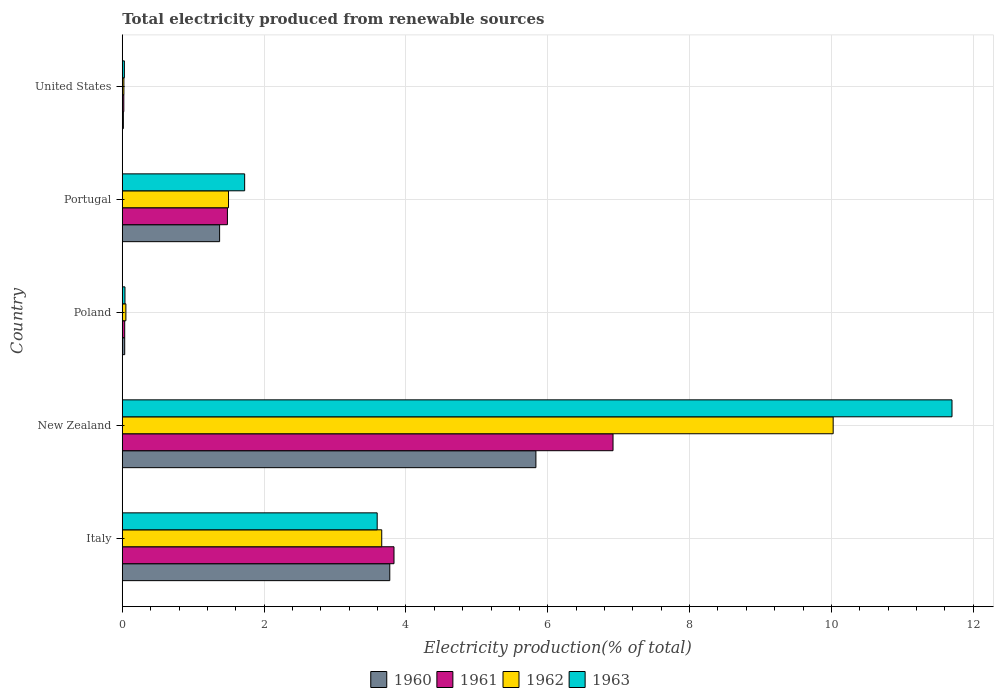How many different coloured bars are there?
Your answer should be very brief. 4. How many groups of bars are there?
Provide a short and direct response. 5. Are the number of bars per tick equal to the number of legend labels?
Your response must be concise. Yes. Are the number of bars on each tick of the Y-axis equal?
Provide a short and direct response. Yes. What is the label of the 1st group of bars from the top?
Offer a terse response. United States. What is the total electricity produced in 1963 in Poland?
Your answer should be compact. 0.04. Across all countries, what is the maximum total electricity produced in 1962?
Your answer should be very brief. 10.02. Across all countries, what is the minimum total electricity produced in 1962?
Keep it short and to the point. 0.02. In which country was the total electricity produced in 1962 maximum?
Your response must be concise. New Zealand. What is the total total electricity produced in 1963 in the graph?
Keep it short and to the point. 17.09. What is the difference between the total electricity produced in 1960 in Poland and that in United States?
Provide a succinct answer. 0.02. What is the difference between the total electricity produced in 1960 in Italy and the total electricity produced in 1961 in Portugal?
Your answer should be compact. 2.29. What is the average total electricity produced in 1960 per country?
Provide a short and direct response. 2.21. What is the difference between the total electricity produced in 1961 and total electricity produced in 1962 in Poland?
Your answer should be very brief. -0.02. In how many countries, is the total electricity produced in 1960 greater than 1.2000000000000002 %?
Offer a terse response. 3. What is the ratio of the total electricity produced in 1963 in Italy to that in United States?
Keep it short and to the point. 122.12. Is the total electricity produced in 1961 in Italy less than that in United States?
Provide a short and direct response. No. Is the difference between the total electricity produced in 1961 in New Zealand and Poland greater than the difference between the total electricity produced in 1962 in New Zealand and Poland?
Keep it short and to the point. No. What is the difference between the highest and the second highest total electricity produced in 1960?
Ensure brevity in your answer.  2.06. What is the difference between the highest and the lowest total electricity produced in 1962?
Offer a very short reply. 10. In how many countries, is the total electricity produced in 1963 greater than the average total electricity produced in 1963 taken over all countries?
Your answer should be compact. 2. What does the 2nd bar from the top in New Zealand represents?
Make the answer very short. 1962. Is it the case that in every country, the sum of the total electricity produced in 1961 and total electricity produced in 1962 is greater than the total electricity produced in 1960?
Keep it short and to the point. Yes. How many countries are there in the graph?
Your response must be concise. 5. What is the difference between two consecutive major ticks on the X-axis?
Provide a short and direct response. 2. Does the graph contain any zero values?
Provide a short and direct response. No. Does the graph contain grids?
Ensure brevity in your answer.  Yes. How are the legend labels stacked?
Ensure brevity in your answer.  Horizontal. What is the title of the graph?
Offer a terse response. Total electricity produced from renewable sources. What is the Electricity production(% of total) in 1960 in Italy?
Offer a terse response. 3.77. What is the Electricity production(% of total) of 1961 in Italy?
Provide a succinct answer. 3.83. What is the Electricity production(% of total) in 1962 in Italy?
Your answer should be compact. 3.66. What is the Electricity production(% of total) of 1963 in Italy?
Give a very brief answer. 3.59. What is the Electricity production(% of total) in 1960 in New Zealand?
Offer a terse response. 5.83. What is the Electricity production(% of total) in 1961 in New Zealand?
Keep it short and to the point. 6.92. What is the Electricity production(% of total) in 1962 in New Zealand?
Keep it short and to the point. 10.02. What is the Electricity production(% of total) of 1963 in New Zealand?
Provide a short and direct response. 11.7. What is the Electricity production(% of total) in 1960 in Poland?
Offer a terse response. 0.03. What is the Electricity production(% of total) in 1961 in Poland?
Offer a terse response. 0.03. What is the Electricity production(% of total) in 1962 in Poland?
Offer a terse response. 0.05. What is the Electricity production(% of total) in 1963 in Poland?
Your response must be concise. 0.04. What is the Electricity production(% of total) in 1960 in Portugal?
Provide a short and direct response. 1.37. What is the Electricity production(% of total) of 1961 in Portugal?
Make the answer very short. 1.48. What is the Electricity production(% of total) of 1962 in Portugal?
Ensure brevity in your answer.  1.5. What is the Electricity production(% of total) of 1963 in Portugal?
Ensure brevity in your answer.  1.73. What is the Electricity production(% of total) in 1960 in United States?
Provide a succinct answer. 0.02. What is the Electricity production(% of total) in 1961 in United States?
Offer a very short reply. 0.02. What is the Electricity production(% of total) of 1962 in United States?
Offer a terse response. 0.02. What is the Electricity production(% of total) in 1963 in United States?
Your answer should be compact. 0.03. Across all countries, what is the maximum Electricity production(% of total) of 1960?
Offer a very short reply. 5.83. Across all countries, what is the maximum Electricity production(% of total) of 1961?
Provide a short and direct response. 6.92. Across all countries, what is the maximum Electricity production(% of total) of 1962?
Make the answer very short. 10.02. Across all countries, what is the maximum Electricity production(% of total) of 1963?
Provide a short and direct response. 11.7. Across all countries, what is the minimum Electricity production(% of total) in 1960?
Keep it short and to the point. 0.02. Across all countries, what is the minimum Electricity production(% of total) in 1961?
Keep it short and to the point. 0.02. Across all countries, what is the minimum Electricity production(% of total) of 1962?
Your answer should be very brief. 0.02. Across all countries, what is the minimum Electricity production(% of total) in 1963?
Make the answer very short. 0.03. What is the total Electricity production(% of total) of 1960 in the graph?
Make the answer very short. 11.03. What is the total Electricity production(% of total) in 1961 in the graph?
Provide a short and direct response. 12.29. What is the total Electricity production(% of total) in 1962 in the graph?
Your answer should be compact. 15.25. What is the total Electricity production(% of total) in 1963 in the graph?
Ensure brevity in your answer.  17.09. What is the difference between the Electricity production(% of total) in 1960 in Italy and that in New Zealand?
Your answer should be very brief. -2.06. What is the difference between the Electricity production(% of total) in 1961 in Italy and that in New Zealand?
Make the answer very short. -3.09. What is the difference between the Electricity production(% of total) of 1962 in Italy and that in New Zealand?
Provide a succinct answer. -6.37. What is the difference between the Electricity production(% of total) of 1963 in Italy and that in New Zealand?
Give a very brief answer. -8.11. What is the difference between the Electricity production(% of total) of 1960 in Italy and that in Poland?
Provide a succinct answer. 3.74. What is the difference between the Electricity production(% of total) of 1961 in Italy and that in Poland?
Your answer should be compact. 3.8. What is the difference between the Electricity production(% of total) of 1962 in Italy and that in Poland?
Provide a short and direct response. 3.61. What is the difference between the Electricity production(% of total) of 1963 in Italy and that in Poland?
Give a very brief answer. 3.56. What is the difference between the Electricity production(% of total) in 1960 in Italy and that in Portugal?
Your answer should be very brief. 2.4. What is the difference between the Electricity production(% of total) in 1961 in Italy and that in Portugal?
Your response must be concise. 2.35. What is the difference between the Electricity production(% of total) in 1962 in Italy and that in Portugal?
Provide a succinct answer. 2.16. What is the difference between the Electricity production(% of total) of 1963 in Italy and that in Portugal?
Offer a terse response. 1.87. What is the difference between the Electricity production(% of total) of 1960 in Italy and that in United States?
Your answer should be compact. 3.76. What is the difference between the Electricity production(% of total) of 1961 in Italy and that in United States?
Give a very brief answer. 3.81. What is the difference between the Electricity production(% of total) in 1962 in Italy and that in United States?
Make the answer very short. 3.64. What is the difference between the Electricity production(% of total) in 1963 in Italy and that in United States?
Keep it short and to the point. 3.56. What is the difference between the Electricity production(% of total) of 1960 in New Zealand and that in Poland?
Provide a short and direct response. 5.8. What is the difference between the Electricity production(% of total) of 1961 in New Zealand and that in Poland?
Give a very brief answer. 6.89. What is the difference between the Electricity production(% of total) in 1962 in New Zealand and that in Poland?
Make the answer very short. 9.97. What is the difference between the Electricity production(% of total) of 1963 in New Zealand and that in Poland?
Provide a succinct answer. 11.66. What is the difference between the Electricity production(% of total) in 1960 in New Zealand and that in Portugal?
Keep it short and to the point. 4.46. What is the difference between the Electricity production(% of total) in 1961 in New Zealand and that in Portugal?
Your response must be concise. 5.44. What is the difference between the Electricity production(% of total) of 1962 in New Zealand and that in Portugal?
Offer a terse response. 8.53. What is the difference between the Electricity production(% of total) in 1963 in New Zealand and that in Portugal?
Provide a short and direct response. 9.97. What is the difference between the Electricity production(% of total) of 1960 in New Zealand and that in United States?
Offer a very short reply. 5.82. What is the difference between the Electricity production(% of total) in 1961 in New Zealand and that in United States?
Provide a short and direct response. 6.9. What is the difference between the Electricity production(% of total) of 1962 in New Zealand and that in United States?
Give a very brief answer. 10. What is the difference between the Electricity production(% of total) in 1963 in New Zealand and that in United States?
Offer a very short reply. 11.67. What is the difference between the Electricity production(% of total) in 1960 in Poland and that in Portugal?
Provide a short and direct response. -1.34. What is the difference between the Electricity production(% of total) of 1961 in Poland and that in Portugal?
Offer a very short reply. -1.45. What is the difference between the Electricity production(% of total) of 1962 in Poland and that in Portugal?
Offer a terse response. -1.45. What is the difference between the Electricity production(% of total) of 1963 in Poland and that in Portugal?
Offer a terse response. -1.69. What is the difference between the Electricity production(% of total) of 1960 in Poland and that in United States?
Give a very brief answer. 0.02. What is the difference between the Electricity production(% of total) of 1961 in Poland and that in United States?
Your answer should be very brief. 0.01. What is the difference between the Electricity production(% of total) of 1962 in Poland and that in United States?
Your answer should be compact. 0.03. What is the difference between the Electricity production(% of total) in 1963 in Poland and that in United States?
Your answer should be very brief. 0.01. What is the difference between the Electricity production(% of total) in 1960 in Portugal and that in United States?
Offer a very short reply. 1.36. What is the difference between the Electricity production(% of total) of 1961 in Portugal and that in United States?
Give a very brief answer. 1.46. What is the difference between the Electricity production(% of total) in 1962 in Portugal and that in United States?
Offer a terse response. 1.48. What is the difference between the Electricity production(% of total) of 1963 in Portugal and that in United States?
Your answer should be very brief. 1.7. What is the difference between the Electricity production(% of total) in 1960 in Italy and the Electricity production(% of total) in 1961 in New Zealand?
Your response must be concise. -3.15. What is the difference between the Electricity production(% of total) in 1960 in Italy and the Electricity production(% of total) in 1962 in New Zealand?
Offer a very short reply. -6.25. What is the difference between the Electricity production(% of total) in 1960 in Italy and the Electricity production(% of total) in 1963 in New Zealand?
Your answer should be compact. -7.93. What is the difference between the Electricity production(% of total) of 1961 in Italy and the Electricity production(% of total) of 1962 in New Zealand?
Your answer should be very brief. -6.19. What is the difference between the Electricity production(% of total) of 1961 in Italy and the Electricity production(% of total) of 1963 in New Zealand?
Offer a terse response. -7.87. What is the difference between the Electricity production(% of total) of 1962 in Italy and the Electricity production(% of total) of 1963 in New Zealand?
Ensure brevity in your answer.  -8.04. What is the difference between the Electricity production(% of total) in 1960 in Italy and the Electricity production(% of total) in 1961 in Poland?
Ensure brevity in your answer.  3.74. What is the difference between the Electricity production(% of total) of 1960 in Italy and the Electricity production(% of total) of 1962 in Poland?
Your answer should be compact. 3.72. What is the difference between the Electricity production(% of total) in 1960 in Italy and the Electricity production(% of total) in 1963 in Poland?
Your answer should be very brief. 3.73. What is the difference between the Electricity production(% of total) of 1961 in Italy and the Electricity production(% of total) of 1962 in Poland?
Your response must be concise. 3.78. What is the difference between the Electricity production(% of total) in 1961 in Italy and the Electricity production(% of total) in 1963 in Poland?
Offer a very short reply. 3.79. What is the difference between the Electricity production(% of total) in 1962 in Italy and the Electricity production(% of total) in 1963 in Poland?
Your answer should be compact. 3.62. What is the difference between the Electricity production(% of total) of 1960 in Italy and the Electricity production(% of total) of 1961 in Portugal?
Provide a succinct answer. 2.29. What is the difference between the Electricity production(% of total) in 1960 in Italy and the Electricity production(% of total) in 1962 in Portugal?
Offer a terse response. 2.27. What is the difference between the Electricity production(% of total) of 1960 in Italy and the Electricity production(% of total) of 1963 in Portugal?
Your answer should be very brief. 2.05. What is the difference between the Electricity production(% of total) in 1961 in Italy and the Electricity production(% of total) in 1962 in Portugal?
Provide a short and direct response. 2.33. What is the difference between the Electricity production(% of total) of 1961 in Italy and the Electricity production(% of total) of 1963 in Portugal?
Offer a very short reply. 2.11. What is the difference between the Electricity production(% of total) of 1962 in Italy and the Electricity production(% of total) of 1963 in Portugal?
Offer a very short reply. 1.93. What is the difference between the Electricity production(% of total) in 1960 in Italy and the Electricity production(% of total) in 1961 in United States?
Ensure brevity in your answer.  3.75. What is the difference between the Electricity production(% of total) in 1960 in Italy and the Electricity production(% of total) in 1962 in United States?
Your answer should be compact. 3.75. What is the difference between the Electricity production(% of total) of 1960 in Italy and the Electricity production(% of total) of 1963 in United States?
Offer a very short reply. 3.74. What is the difference between the Electricity production(% of total) of 1961 in Italy and the Electricity production(% of total) of 1962 in United States?
Give a very brief answer. 3.81. What is the difference between the Electricity production(% of total) of 1961 in Italy and the Electricity production(% of total) of 1963 in United States?
Keep it short and to the point. 3.8. What is the difference between the Electricity production(% of total) of 1962 in Italy and the Electricity production(% of total) of 1963 in United States?
Give a very brief answer. 3.63. What is the difference between the Electricity production(% of total) of 1960 in New Zealand and the Electricity production(% of total) of 1961 in Poland?
Provide a short and direct response. 5.8. What is the difference between the Electricity production(% of total) in 1960 in New Zealand and the Electricity production(% of total) in 1962 in Poland?
Offer a very short reply. 5.78. What is the difference between the Electricity production(% of total) in 1960 in New Zealand and the Electricity production(% of total) in 1963 in Poland?
Ensure brevity in your answer.  5.79. What is the difference between the Electricity production(% of total) in 1961 in New Zealand and the Electricity production(% of total) in 1962 in Poland?
Keep it short and to the point. 6.87. What is the difference between the Electricity production(% of total) of 1961 in New Zealand and the Electricity production(% of total) of 1963 in Poland?
Give a very brief answer. 6.88. What is the difference between the Electricity production(% of total) in 1962 in New Zealand and the Electricity production(% of total) in 1963 in Poland?
Give a very brief answer. 9.99. What is the difference between the Electricity production(% of total) in 1960 in New Zealand and the Electricity production(% of total) in 1961 in Portugal?
Provide a short and direct response. 4.35. What is the difference between the Electricity production(% of total) of 1960 in New Zealand and the Electricity production(% of total) of 1962 in Portugal?
Give a very brief answer. 4.33. What is the difference between the Electricity production(% of total) of 1960 in New Zealand and the Electricity production(% of total) of 1963 in Portugal?
Keep it short and to the point. 4.11. What is the difference between the Electricity production(% of total) in 1961 in New Zealand and the Electricity production(% of total) in 1962 in Portugal?
Keep it short and to the point. 5.42. What is the difference between the Electricity production(% of total) in 1961 in New Zealand and the Electricity production(% of total) in 1963 in Portugal?
Your answer should be compact. 5.19. What is the difference between the Electricity production(% of total) in 1962 in New Zealand and the Electricity production(% of total) in 1963 in Portugal?
Provide a short and direct response. 8.3. What is the difference between the Electricity production(% of total) in 1960 in New Zealand and the Electricity production(% of total) in 1961 in United States?
Provide a short and direct response. 5.81. What is the difference between the Electricity production(% of total) in 1960 in New Zealand and the Electricity production(% of total) in 1962 in United States?
Give a very brief answer. 5.81. What is the difference between the Electricity production(% of total) in 1960 in New Zealand and the Electricity production(% of total) in 1963 in United States?
Keep it short and to the point. 5.8. What is the difference between the Electricity production(% of total) of 1961 in New Zealand and the Electricity production(% of total) of 1962 in United States?
Provide a succinct answer. 6.9. What is the difference between the Electricity production(% of total) in 1961 in New Zealand and the Electricity production(% of total) in 1963 in United States?
Make the answer very short. 6.89. What is the difference between the Electricity production(% of total) in 1962 in New Zealand and the Electricity production(% of total) in 1963 in United States?
Ensure brevity in your answer.  10. What is the difference between the Electricity production(% of total) of 1960 in Poland and the Electricity production(% of total) of 1961 in Portugal?
Offer a very short reply. -1.45. What is the difference between the Electricity production(% of total) in 1960 in Poland and the Electricity production(% of total) in 1962 in Portugal?
Give a very brief answer. -1.46. What is the difference between the Electricity production(% of total) in 1960 in Poland and the Electricity production(% of total) in 1963 in Portugal?
Provide a succinct answer. -1.69. What is the difference between the Electricity production(% of total) of 1961 in Poland and the Electricity production(% of total) of 1962 in Portugal?
Your answer should be compact. -1.46. What is the difference between the Electricity production(% of total) in 1961 in Poland and the Electricity production(% of total) in 1963 in Portugal?
Offer a terse response. -1.69. What is the difference between the Electricity production(% of total) of 1962 in Poland and the Electricity production(% of total) of 1963 in Portugal?
Your response must be concise. -1.67. What is the difference between the Electricity production(% of total) in 1960 in Poland and the Electricity production(% of total) in 1961 in United States?
Your response must be concise. 0.01. What is the difference between the Electricity production(% of total) of 1960 in Poland and the Electricity production(% of total) of 1962 in United States?
Your answer should be compact. 0.01. What is the difference between the Electricity production(% of total) of 1960 in Poland and the Electricity production(% of total) of 1963 in United States?
Give a very brief answer. 0. What is the difference between the Electricity production(% of total) in 1961 in Poland and the Electricity production(% of total) in 1962 in United States?
Ensure brevity in your answer.  0.01. What is the difference between the Electricity production(% of total) in 1961 in Poland and the Electricity production(% of total) in 1963 in United States?
Offer a very short reply. 0. What is the difference between the Electricity production(% of total) in 1962 in Poland and the Electricity production(% of total) in 1963 in United States?
Make the answer very short. 0.02. What is the difference between the Electricity production(% of total) of 1960 in Portugal and the Electricity production(% of total) of 1961 in United States?
Your response must be concise. 1.35. What is the difference between the Electricity production(% of total) in 1960 in Portugal and the Electricity production(% of total) in 1962 in United States?
Offer a very short reply. 1.35. What is the difference between the Electricity production(% of total) in 1960 in Portugal and the Electricity production(% of total) in 1963 in United States?
Offer a very short reply. 1.34. What is the difference between the Electricity production(% of total) of 1961 in Portugal and the Electricity production(% of total) of 1962 in United States?
Offer a terse response. 1.46. What is the difference between the Electricity production(% of total) in 1961 in Portugal and the Electricity production(% of total) in 1963 in United States?
Keep it short and to the point. 1.45. What is the difference between the Electricity production(% of total) in 1962 in Portugal and the Electricity production(% of total) in 1963 in United States?
Provide a succinct answer. 1.47. What is the average Electricity production(% of total) in 1960 per country?
Offer a terse response. 2.21. What is the average Electricity production(% of total) of 1961 per country?
Your response must be concise. 2.46. What is the average Electricity production(% of total) of 1962 per country?
Provide a succinct answer. 3.05. What is the average Electricity production(% of total) of 1963 per country?
Your answer should be very brief. 3.42. What is the difference between the Electricity production(% of total) of 1960 and Electricity production(% of total) of 1961 in Italy?
Provide a short and direct response. -0.06. What is the difference between the Electricity production(% of total) in 1960 and Electricity production(% of total) in 1962 in Italy?
Make the answer very short. 0.11. What is the difference between the Electricity production(% of total) in 1960 and Electricity production(% of total) in 1963 in Italy?
Ensure brevity in your answer.  0.18. What is the difference between the Electricity production(% of total) in 1961 and Electricity production(% of total) in 1962 in Italy?
Keep it short and to the point. 0.17. What is the difference between the Electricity production(% of total) of 1961 and Electricity production(% of total) of 1963 in Italy?
Provide a succinct answer. 0.24. What is the difference between the Electricity production(% of total) of 1962 and Electricity production(% of total) of 1963 in Italy?
Your answer should be very brief. 0.06. What is the difference between the Electricity production(% of total) in 1960 and Electricity production(% of total) in 1961 in New Zealand?
Keep it short and to the point. -1.09. What is the difference between the Electricity production(% of total) in 1960 and Electricity production(% of total) in 1962 in New Zealand?
Your response must be concise. -4.19. What is the difference between the Electricity production(% of total) in 1960 and Electricity production(% of total) in 1963 in New Zealand?
Keep it short and to the point. -5.87. What is the difference between the Electricity production(% of total) in 1961 and Electricity production(% of total) in 1962 in New Zealand?
Give a very brief answer. -3.1. What is the difference between the Electricity production(% of total) of 1961 and Electricity production(% of total) of 1963 in New Zealand?
Give a very brief answer. -4.78. What is the difference between the Electricity production(% of total) in 1962 and Electricity production(% of total) in 1963 in New Zealand?
Ensure brevity in your answer.  -1.68. What is the difference between the Electricity production(% of total) in 1960 and Electricity production(% of total) in 1961 in Poland?
Ensure brevity in your answer.  0. What is the difference between the Electricity production(% of total) in 1960 and Electricity production(% of total) in 1962 in Poland?
Provide a succinct answer. -0.02. What is the difference between the Electricity production(% of total) of 1960 and Electricity production(% of total) of 1963 in Poland?
Ensure brevity in your answer.  -0. What is the difference between the Electricity production(% of total) of 1961 and Electricity production(% of total) of 1962 in Poland?
Provide a short and direct response. -0.02. What is the difference between the Electricity production(% of total) in 1961 and Electricity production(% of total) in 1963 in Poland?
Give a very brief answer. -0. What is the difference between the Electricity production(% of total) of 1962 and Electricity production(% of total) of 1963 in Poland?
Offer a very short reply. 0.01. What is the difference between the Electricity production(% of total) in 1960 and Electricity production(% of total) in 1961 in Portugal?
Keep it short and to the point. -0.11. What is the difference between the Electricity production(% of total) in 1960 and Electricity production(% of total) in 1962 in Portugal?
Provide a short and direct response. -0.13. What is the difference between the Electricity production(% of total) in 1960 and Electricity production(% of total) in 1963 in Portugal?
Make the answer very short. -0.35. What is the difference between the Electricity production(% of total) of 1961 and Electricity production(% of total) of 1962 in Portugal?
Provide a short and direct response. -0.02. What is the difference between the Electricity production(% of total) of 1961 and Electricity production(% of total) of 1963 in Portugal?
Offer a terse response. -0.24. What is the difference between the Electricity production(% of total) of 1962 and Electricity production(% of total) of 1963 in Portugal?
Your answer should be compact. -0.23. What is the difference between the Electricity production(% of total) in 1960 and Electricity production(% of total) in 1961 in United States?
Keep it short and to the point. -0.01. What is the difference between the Electricity production(% of total) in 1960 and Electricity production(% of total) in 1962 in United States?
Provide a short and direct response. -0.01. What is the difference between the Electricity production(% of total) in 1960 and Electricity production(% of total) in 1963 in United States?
Provide a succinct answer. -0.01. What is the difference between the Electricity production(% of total) of 1961 and Electricity production(% of total) of 1962 in United States?
Offer a terse response. -0. What is the difference between the Electricity production(% of total) in 1961 and Electricity production(% of total) in 1963 in United States?
Provide a short and direct response. -0.01. What is the difference between the Electricity production(% of total) in 1962 and Electricity production(% of total) in 1963 in United States?
Offer a very short reply. -0.01. What is the ratio of the Electricity production(% of total) of 1960 in Italy to that in New Zealand?
Keep it short and to the point. 0.65. What is the ratio of the Electricity production(% of total) of 1961 in Italy to that in New Zealand?
Offer a very short reply. 0.55. What is the ratio of the Electricity production(% of total) in 1962 in Italy to that in New Zealand?
Offer a terse response. 0.36. What is the ratio of the Electricity production(% of total) of 1963 in Italy to that in New Zealand?
Make the answer very short. 0.31. What is the ratio of the Electricity production(% of total) of 1960 in Italy to that in Poland?
Your answer should be very brief. 110.45. What is the ratio of the Electricity production(% of total) of 1961 in Italy to that in Poland?
Offer a very short reply. 112.3. What is the ratio of the Electricity production(% of total) in 1962 in Italy to that in Poland?
Your answer should be compact. 71.88. What is the ratio of the Electricity production(% of total) of 1963 in Italy to that in Poland?
Your response must be concise. 94.84. What is the ratio of the Electricity production(% of total) of 1960 in Italy to that in Portugal?
Make the answer very short. 2.75. What is the ratio of the Electricity production(% of total) in 1961 in Italy to that in Portugal?
Provide a succinct answer. 2.58. What is the ratio of the Electricity production(% of total) in 1962 in Italy to that in Portugal?
Your response must be concise. 2.44. What is the ratio of the Electricity production(% of total) of 1963 in Italy to that in Portugal?
Provide a short and direct response. 2.08. What is the ratio of the Electricity production(% of total) in 1960 in Italy to that in United States?
Provide a short and direct response. 247.25. What is the ratio of the Electricity production(% of total) in 1961 in Italy to that in United States?
Keep it short and to the point. 177.87. What is the ratio of the Electricity production(% of total) of 1962 in Italy to that in United States?
Your response must be concise. 160.56. What is the ratio of the Electricity production(% of total) of 1963 in Italy to that in United States?
Your response must be concise. 122.12. What is the ratio of the Electricity production(% of total) in 1960 in New Zealand to that in Poland?
Ensure brevity in your answer.  170.79. What is the ratio of the Electricity production(% of total) of 1961 in New Zealand to that in Poland?
Offer a terse response. 202.83. What is the ratio of the Electricity production(% of total) of 1962 in New Zealand to that in Poland?
Provide a short and direct response. 196.95. What is the ratio of the Electricity production(% of total) of 1963 in New Zealand to that in Poland?
Your answer should be very brief. 308.73. What is the ratio of the Electricity production(% of total) in 1960 in New Zealand to that in Portugal?
Offer a terse response. 4.25. What is the ratio of the Electricity production(% of total) of 1961 in New Zealand to that in Portugal?
Ensure brevity in your answer.  4.67. What is the ratio of the Electricity production(% of total) of 1962 in New Zealand to that in Portugal?
Offer a very short reply. 6.69. What is the ratio of the Electricity production(% of total) in 1963 in New Zealand to that in Portugal?
Your answer should be compact. 6.78. What is the ratio of the Electricity production(% of total) of 1960 in New Zealand to that in United States?
Provide a succinct answer. 382.31. What is the ratio of the Electricity production(% of total) of 1961 in New Zealand to that in United States?
Your response must be concise. 321.25. What is the ratio of the Electricity production(% of total) in 1962 in New Zealand to that in United States?
Provide a short and direct response. 439.93. What is the ratio of the Electricity production(% of total) of 1963 in New Zealand to that in United States?
Provide a short and direct response. 397.5. What is the ratio of the Electricity production(% of total) of 1960 in Poland to that in Portugal?
Give a very brief answer. 0.02. What is the ratio of the Electricity production(% of total) of 1961 in Poland to that in Portugal?
Your answer should be compact. 0.02. What is the ratio of the Electricity production(% of total) in 1962 in Poland to that in Portugal?
Your answer should be very brief. 0.03. What is the ratio of the Electricity production(% of total) in 1963 in Poland to that in Portugal?
Keep it short and to the point. 0.02. What is the ratio of the Electricity production(% of total) in 1960 in Poland to that in United States?
Offer a very short reply. 2.24. What is the ratio of the Electricity production(% of total) of 1961 in Poland to that in United States?
Make the answer very short. 1.58. What is the ratio of the Electricity production(% of total) in 1962 in Poland to that in United States?
Your answer should be compact. 2.23. What is the ratio of the Electricity production(% of total) of 1963 in Poland to that in United States?
Keep it short and to the point. 1.29. What is the ratio of the Electricity production(% of total) in 1960 in Portugal to that in United States?
Your response must be concise. 89.96. What is the ratio of the Electricity production(% of total) of 1961 in Portugal to that in United States?
Make the answer very short. 68.83. What is the ratio of the Electricity production(% of total) in 1962 in Portugal to that in United States?
Your answer should be very brief. 65.74. What is the ratio of the Electricity production(% of total) of 1963 in Portugal to that in United States?
Your answer should be compact. 58.63. What is the difference between the highest and the second highest Electricity production(% of total) of 1960?
Keep it short and to the point. 2.06. What is the difference between the highest and the second highest Electricity production(% of total) of 1961?
Make the answer very short. 3.09. What is the difference between the highest and the second highest Electricity production(% of total) of 1962?
Provide a succinct answer. 6.37. What is the difference between the highest and the second highest Electricity production(% of total) in 1963?
Offer a terse response. 8.11. What is the difference between the highest and the lowest Electricity production(% of total) of 1960?
Keep it short and to the point. 5.82. What is the difference between the highest and the lowest Electricity production(% of total) of 1961?
Your response must be concise. 6.9. What is the difference between the highest and the lowest Electricity production(% of total) in 1962?
Your answer should be very brief. 10. What is the difference between the highest and the lowest Electricity production(% of total) in 1963?
Ensure brevity in your answer.  11.67. 